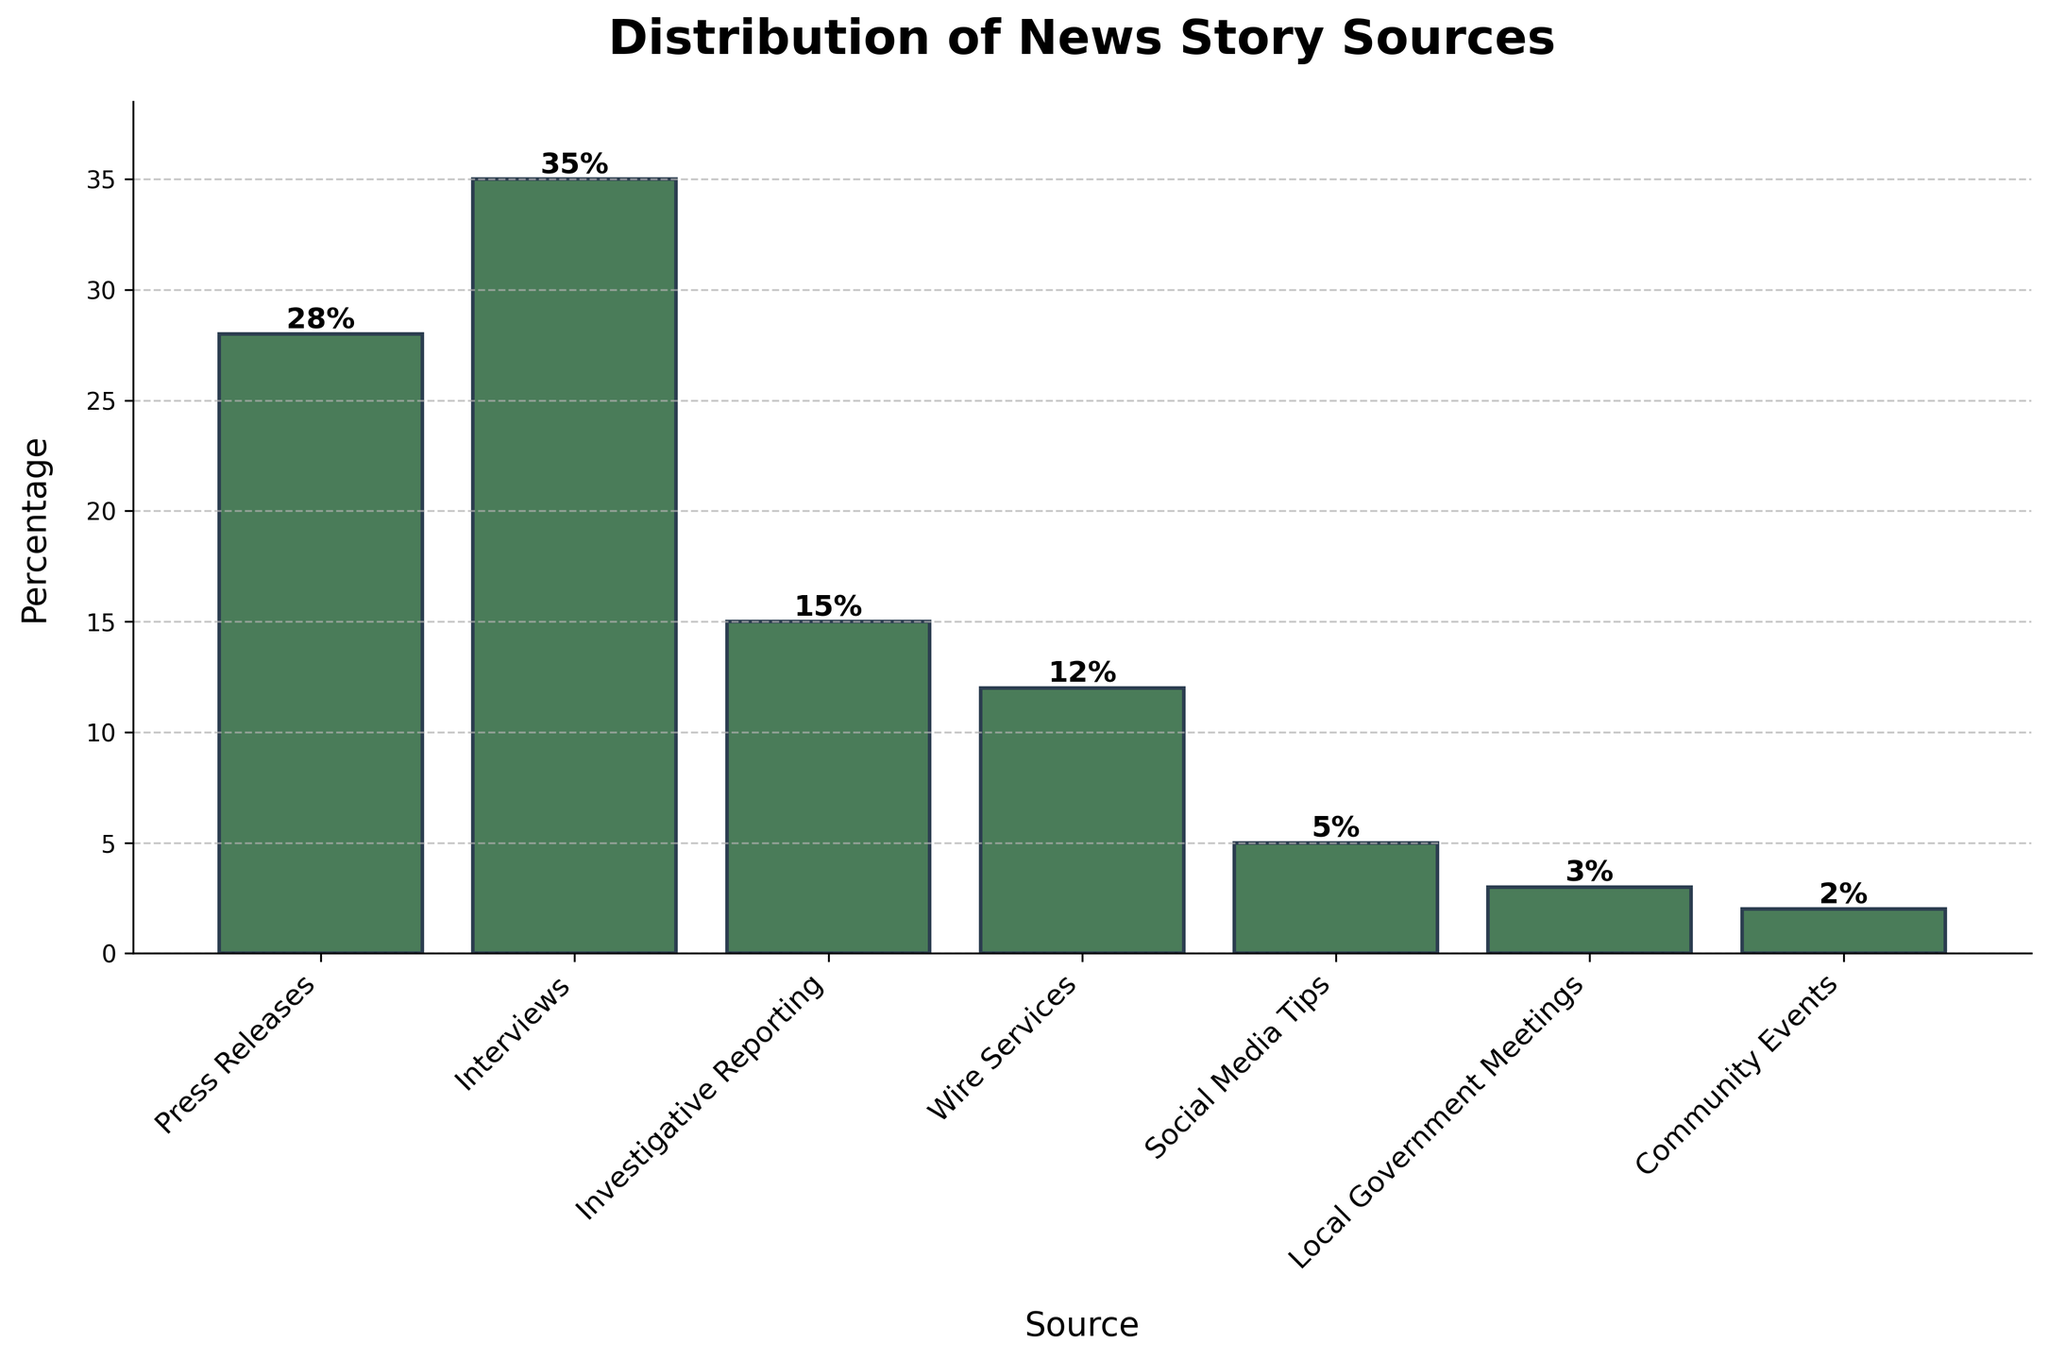What's the largest source of news stories according to the chart? The largest source of news stories can be identified by looking for the tallest bar on the chart. The tallest bar corresponds to "Interviews" with a height of 35%.
Answer: Interviews Which source has the smallest percentage of news stories? The source with the smallest percentage of news stories corresponds to the shortest bar on the chart. The smallest bar represents "Community Events" with a height of 2%.
Answer: Community Events How many percentage points higher are news stories from interviews compared to investigative reporting? To find the difference, subtract the percentage of "Investigative Reporting" from "Interviews". The percentage for "Interviews" is 35%, and for "Investigative Reporting" is 15%. So, 35% - 15% = 20%.
Answer: 20% What is the combined percentage of news stories from press releases and wire services? To find the combined percentage, add the percentages of "Press Releases" and "Wire Services". The percentages are 28% and 12%, respectively. So, 28% + 12% = 40%.
Answer: 40% Are there more news stories from local government meetings or community events? Compare the heights of the bars for "Local Government Meetings" and "Community Events". The percentage for "Local Government Meetings" is 3%, while for "Community Events" is 2%.
Answer: Local Government Meetings Which source's percentage of news stories is closest to the value of 10%? Examine the percentages near 10%. "Wire Services" is closest with a percentage of 12%.
Answer: Wire Services What is the total percentage of news stories that come from sources other than interviews and press releases? Add up the percentages of all sources excluding "Interviews" (35%) and "Press Releases" (28%). The remaining sources are "Investigative Reporting" (15%), "Wire Services" (12%), "Social Media Tips" (5%), "Local Government Meetings" (3%), and "Community Events" (2%). 15% + 12% + 5% + 3% + 2% = 37%.
Answer: 37% Which two categories, when combined, have a total percentage equal to the percentage of stories from interviews? Find two categories whose combined percentage equals 35% (the percentage from Interviews). "Press Releases" (28%) and "Investigative Reporting" (15%) add up to 43%, but "Press Releases" (28%) and "Wire Services" (12%) add up to 40%, and none of them sum exactly to 35%. Therefore, no exact match is found.
Answer: None 